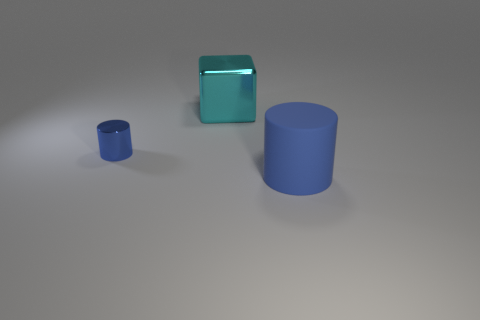Subtract all brown cylinders. Subtract all brown spheres. How many cylinders are left? 2 Add 2 small purple shiny cubes. How many objects exist? 5 Subtract all blocks. How many objects are left? 2 Subtract 0 purple cylinders. How many objects are left? 3 Subtract all tiny blue cylinders. Subtract all tiny blue things. How many objects are left? 1 Add 2 matte cylinders. How many matte cylinders are left? 3 Add 1 large red rubber blocks. How many large red rubber blocks exist? 1 